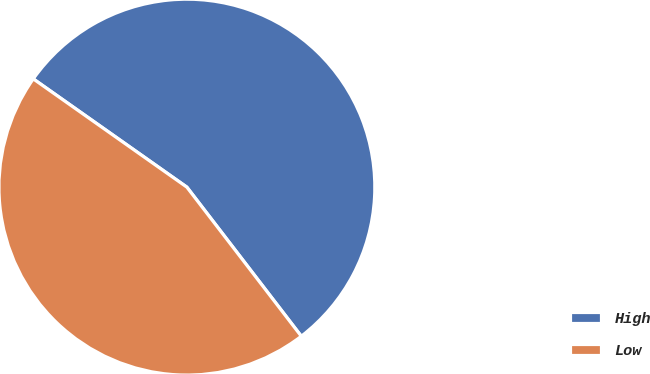Convert chart to OTSL. <chart><loc_0><loc_0><loc_500><loc_500><pie_chart><fcel>High<fcel>Low<nl><fcel>54.81%<fcel>45.19%<nl></chart> 